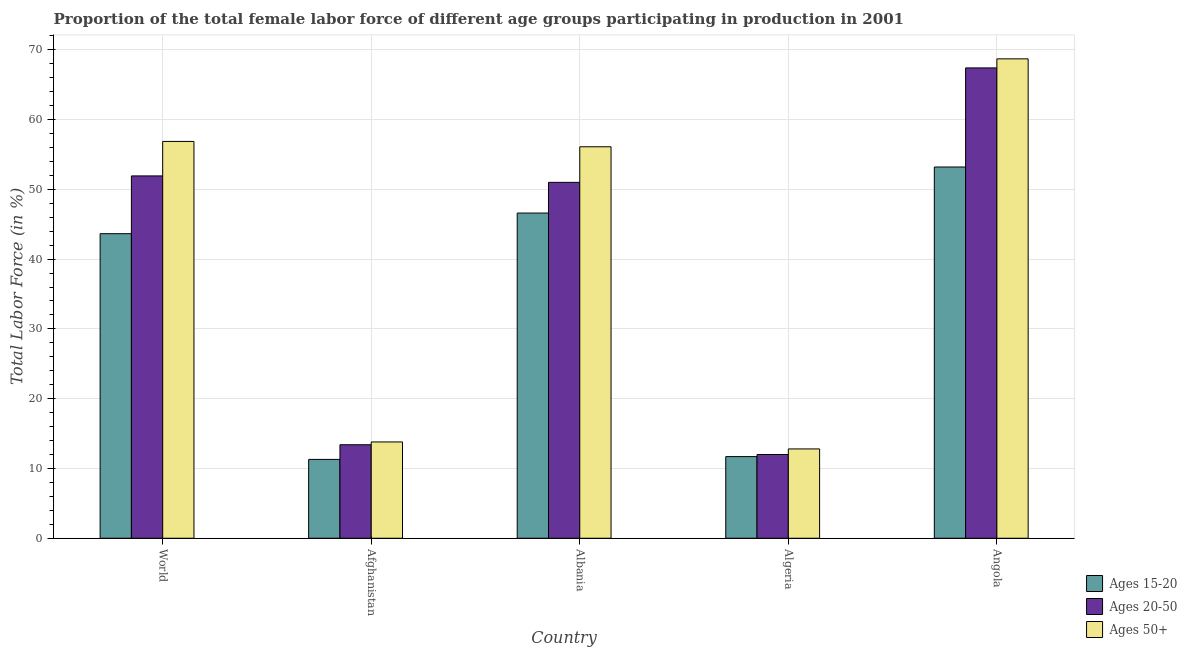How many different coloured bars are there?
Ensure brevity in your answer.  3. Are the number of bars per tick equal to the number of legend labels?
Your answer should be compact. Yes. What is the label of the 5th group of bars from the left?
Make the answer very short. Angola. What is the percentage of female labor force within the age group 15-20 in Algeria?
Your answer should be very brief. 11.7. Across all countries, what is the maximum percentage of female labor force within the age group 20-50?
Your response must be concise. 67.4. Across all countries, what is the minimum percentage of female labor force within the age group 20-50?
Offer a terse response. 12. In which country was the percentage of female labor force above age 50 maximum?
Provide a succinct answer. Angola. In which country was the percentage of female labor force above age 50 minimum?
Provide a succinct answer. Algeria. What is the total percentage of female labor force above age 50 in the graph?
Offer a very short reply. 208.27. What is the difference between the percentage of female labor force above age 50 in Afghanistan and that in Angola?
Make the answer very short. -54.9. What is the difference between the percentage of female labor force within the age group 15-20 in Angola and the percentage of female labor force within the age group 20-50 in Algeria?
Your answer should be very brief. 41.2. What is the average percentage of female labor force within the age group 20-50 per country?
Make the answer very short. 39.14. What is the difference between the percentage of female labor force within the age group 20-50 and percentage of female labor force above age 50 in World?
Keep it short and to the point. -4.94. What is the ratio of the percentage of female labor force within the age group 20-50 in Albania to that in Algeria?
Make the answer very short. 4.25. Is the percentage of female labor force within the age group 20-50 in Albania less than that in World?
Provide a succinct answer. Yes. What is the difference between the highest and the second highest percentage of female labor force within the age group 20-50?
Your answer should be very brief. 15.48. What is the difference between the highest and the lowest percentage of female labor force above age 50?
Offer a terse response. 55.9. In how many countries, is the percentage of female labor force above age 50 greater than the average percentage of female labor force above age 50 taken over all countries?
Make the answer very short. 3. Is the sum of the percentage of female labor force within the age group 20-50 in Albania and Angola greater than the maximum percentage of female labor force within the age group 15-20 across all countries?
Make the answer very short. Yes. What does the 1st bar from the left in Algeria represents?
Provide a succinct answer. Ages 15-20. What does the 3rd bar from the right in Angola represents?
Offer a terse response. Ages 15-20. Is it the case that in every country, the sum of the percentage of female labor force within the age group 15-20 and percentage of female labor force within the age group 20-50 is greater than the percentage of female labor force above age 50?
Your answer should be very brief. Yes. How many bars are there?
Keep it short and to the point. 15. Are all the bars in the graph horizontal?
Give a very brief answer. No. Where does the legend appear in the graph?
Offer a very short reply. Bottom right. What is the title of the graph?
Provide a succinct answer. Proportion of the total female labor force of different age groups participating in production in 2001. What is the label or title of the X-axis?
Keep it short and to the point. Country. What is the Total Labor Force (in %) of Ages 15-20 in World?
Make the answer very short. 43.64. What is the Total Labor Force (in %) of Ages 20-50 in World?
Make the answer very short. 51.92. What is the Total Labor Force (in %) of Ages 50+ in World?
Offer a terse response. 56.87. What is the Total Labor Force (in %) in Ages 15-20 in Afghanistan?
Your response must be concise. 11.3. What is the Total Labor Force (in %) in Ages 20-50 in Afghanistan?
Your response must be concise. 13.4. What is the Total Labor Force (in %) in Ages 50+ in Afghanistan?
Make the answer very short. 13.8. What is the Total Labor Force (in %) of Ages 15-20 in Albania?
Provide a short and direct response. 46.6. What is the Total Labor Force (in %) in Ages 50+ in Albania?
Keep it short and to the point. 56.1. What is the Total Labor Force (in %) in Ages 15-20 in Algeria?
Make the answer very short. 11.7. What is the Total Labor Force (in %) in Ages 20-50 in Algeria?
Offer a very short reply. 12. What is the Total Labor Force (in %) of Ages 50+ in Algeria?
Ensure brevity in your answer.  12.8. What is the Total Labor Force (in %) of Ages 15-20 in Angola?
Make the answer very short. 53.2. What is the Total Labor Force (in %) of Ages 20-50 in Angola?
Offer a very short reply. 67.4. What is the Total Labor Force (in %) of Ages 50+ in Angola?
Provide a short and direct response. 68.7. Across all countries, what is the maximum Total Labor Force (in %) in Ages 15-20?
Offer a terse response. 53.2. Across all countries, what is the maximum Total Labor Force (in %) in Ages 20-50?
Offer a terse response. 67.4. Across all countries, what is the maximum Total Labor Force (in %) of Ages 50+?
Your answer should be compact. 68.7. Across all countries, what is the minimum Total Labor Force (in %) of Ages 15-20?
Your answer should be very brief. 11.3. Across all countries, what is the minimum Total Labor Force (in %) of Ages 20-50?
Give a very brief answer. 12. Across all countries, what is the minimum Total Labor Force (in %) in Ages 50+?
Offer a terse response. 12.8. What is the total Total Labor Force (in %) in Ages 15-20 in the graph?
Provide a succinct answer. 166.44. What is the total Total Labor Force (in %) in Ages 20-50 in the graph?
Your answer should be very brief. 195.72. What is the total Total Labor Force (in %) in Ages 50+ in the graph?
Provide a short and direct response. 208.27. What is the difference between the Total Labor Force (in %) of Ages 15-20 in World and that in Afghanistan?
Offer a very short reply. 32.34. What is the difference between the Total Labor Force (in %) of Ages 20-50 in World and that in Afghanistan?
Your answer should be very brief. 38.52. What is the difference between the Total Labor Force (in %) in Ages 50+ in World and that in Afghanistan?
Your response must be concise. 43.07. What is the difference between the Total Labor Force (in %) of Ages 15-20 in World and that in Albania?
Your response must be concise. -2.96. What is the difference between the Total Labor Force (in %) of Ages 20-50 in World and that in Albania?
Your answer should be very brief. 0.92. What is the difference between the Total Labor Force (in %) of Ages 50+ in World and that in Albania?
Offer a very short reply. 0.77. What is the difference between the Total Labor Force (in %) of Ages 15-20 in World and that in Algeria?
Provide a short and direct response. 31.94. What is the difference between the Total Labor Force (in %) of Ages 20-50 in World and that in Algeria?
Your answer should be very brief. 39.92. What is the difference between the Total Labor Force (in %) in Ages 50+ in World and that in Algeria?
Give a very brief answer. 44.07. What is the difference between the Total Labor Force (in %) of Ages 15-20 in World and that in Angola?
Your answer should be compact. -9.56. What is the difference between the Total Labor Force (in %) in Ages 20-50 in World and that in Angola?
Provide a succinct answer. -15.48. What is the difference between the Total Labor Force (in %) of Ages 50+ in World and that in Angola?
Make the answer very short. -11.83. What is the difference between the Total Labor Force (in %) in Ages 15-20 in Afghanistan and that in Albania?
Your answer should be very brief. -35.3. What is the difference between the Total Labor Force (in %) in Ages 20-50 in Afghanistan and that in Albania?
Your answer should be compact. -37.6. What is the difference between the Total Labor Force (in %) in Ages 50+ in Afghanistan and that in Albania?
Provide a succinct answer. -42.3. What is the difference between the Total Labor Force (in %) in Ages 15-20 in Afghanistan and that in Algeria?
Offer a very short reply. -0.4. What is the difference between the Total Labor Force (in %) in Ages 20-50 in Afghanistan and that in Algeria?
Offer a terse response. 1.4. What is the difference between the Total Labor Force (in %) of Ages 15-20 in Afghanistan and that in Angola?
Your response must be concise. -41.9. What is the difference between the Total Labor Force (in %) of Ages 20-50 in Afghanistan and that in Angola?
Provide a succinct answer. -54. What is the difference between the Total Labor Force (in %) of Ages 50+ in Afghanistan and that in Angola?
Your answer should be compact. -54.9. What is the difference between the Total Labor Force (in %) of Ages 15-20 in Albania and that in Algeria?
Ensure brevity in your answer.  34.9. What is the difference between the Total Labor Force (in %) in Ages 50+ in Albania and that in Algeria?
Provide a short and direct response. 43.3. What is the difference between the Total Labor Force (in %) of Ages 20-50 in Albania and that in Angola?
Ensure brevity in your answer.  -16.4. What is the difference between the Total Labor Force (in %) of Ages 15-20 in Algeria and that in Angola?
Give a very brief answer. -41.5. What is the difference between the Total Labor Force (in %) of Ages 20-50 in Algeria and that in Angola?
Your answer should be compact. -55.4. What is the difference between the Total Labor Force (in %) of Ages 50+ in Algeria and that in Angola?
Your answer should be very brief. -55.9. What is the difference between the Total Labor Force (in %) in Ages 15-20 in World and the Total Labor Force (in %) in Ages 20-50 in Afghanistan?
Your answer should be compact. 30.24. What is the difference between the Total Labor Force (in %) of Ages 15-20 in World and the Total Labor Force (in %) of Ages 50+ in Afghanistan?
Ensure brevity in your answer.  29.84. What is the difference between the Total Labor Force (in %) in Ages 20-50 in World and the Total Labor Force (in %) in Ages 50+ in Afghanistan?
Your answer should be very brief. 38.12. What is the difference between the Total Labor Force (in %) of Ages 15-20 in World and the Total Labor Force (in %) of Ages 20-50 in Albania?
Make the answer very short. -7.36. What is the difference between the Total Labor Force (in %) of Ages 15-20 in World and the Total Labor Force (in %) of Ages 50+ in Albania?
Provide a short and direct response. -12.46. What is the difference between the Total Labor Force (in %) of Ages 20-50 in World and the Total Labor Force (in %) of Ages 50+ in Albania?
Offer a terse response. -4.18. What is the difference between the Total Labor Force (in %) of Ages 15-20 in World and the Total Labor Force (in %) of Ages 20-50 in Algeria?
Give a very brief answer. 31.64. What is the difference between the Total Labor Force (in %) in Ages 15-20 in World and the Total Labor Force (in %) in Ages 50+ in Algeria?
Your answer should be very brief. 30.84. What is the difference between the Total Labor Force (in %) in Ages 20-50 in World and the Total Labor Force (in %) in Ages 50+ in Algeria?
Offer a very short reply. 39.12. What is the difference between the Total Labor Force (in %) of Ages 15-20 in World and the Total Labor Force (in %) of Ages 20-50 in Angola?
Offer a very short reply. -23.76. What is the difference between the Total Labor Force (in %) in Ages 15-20 in World and the Total Labor Force (in %) in Ages 50+ in Angola?
Your response must be concise. -25.06. What is the difference between the Total Labor Force (in %) in Ages 20-50 in World and the Total Labor Force (in %) in Ages 50+ in Angola?
Provide a short and direct response. -16.78. What is the difference between the Total Labor Force (in %) of Ages 15-20 in Afghanistan and the Total Labor Force (in %) of Ages 20-50 in Albania?
Offer a terse response. -39.7. What is the difference between the Total Labor Force (in %) in Ages 15-20 in Afghanistan and the Total Labor Force (in %) in Ages 50+ in Albania?
Give a very brief answer. -44.8. What is the difference between the Total Labor Force (in %) in Ages 20-50 in Afghanistan and the Total Labor Force (in %) in Ages 50+ in Albania?
Your response must be concise. -42.7. What is the difference between the Total Labor Force (in %) in Ages 15-20 in Afghanistan and the Total Labor Force (in %) in Ages 20-50 in Algeria?
Make the answer very short. -0.7. What is the difference between the Total Labor Force (in %) of Ages 15-20 in Afghanistan and the Total Labor Force (in %) of Ages 20-50 in Angola?
Make the answer very short. -56.1. What is the difference between the Total Labor Force (in %) in Ages 15-20 in Afghanistan and the Total Labor Force (in %) in Ages 50+ in Angola?
Keep it short and to the point. -57.4. What is the difference between the Total Labor Force (in %) of Ages 20-50 in Afghanistan and the Total Labor Force (in %) of Ages 50+ in Angola?
Your response must be concise. -55.3. What is the difference between the Total Labor Force (in %) in Ages 15-20 in Albania and the Total Labor Force (in %) in Ages 20-50 in Algeria?
Offer a very short reply. 34.6. What is the difference between the Total Labor Force (in %) of Ages 15-20 in Albania and the Total Labor Force (in %) of Ages 50+ in Algeria?
Make the answer very short. 33.8. What is the difference between the Total Labor Force (in %) in Ages 20-50 in Albania and the Total Labor Force (in %) in Ages 50+ in Algeria?
Give a very brief answer. 38.2. What is the difference between the Total Labor Force (in %) of Ages 15-20 in Albania and the Total Labor Force (in %) of Ages 20-50 in Angola?
Your response must be concise. -20.8. What is the difference between the Total Labor Force (in %) of Ages 15-20 in Albania and the Total Labor Force (in %) of Ages 50+ in Angola?
Your answer should be compact. -22.1. What is the difference between the Total Labor Force (in %) of Ages 20-50 in Albania and the Total Labor Force (in %) of Ages 50+ in Angola?
Your answer should be compact. -17.7. What is the difference between the Total Labor Force (in %) in Ages 15-20 in Algeria and the Total Labor Force (in %) in Ages 20-50 in Angola?
Your response must be concise. -55.7. What is the difference between the Total Labor Force (in %) in Ages 15-20 in Algeria and the Total Labor Force (in %) in Ages 50+ in Angola?
Ensure brevity in your answer.  -57. What is the difference between the Total Labor Force (in %) in Ages 20-50 in Algeria and the Total Labor Force (in %) in Ages 50+ in Angola?
Ensure brevity in your answer.  -56.7. What is the average Total Labor Force (in %) of Ages 15-20 per country?
Ensure brevity in your answer.  33.29. What is the average Total Labor Force (in %) in Ages 20-50 per country?
Ensure brevity in your answer.  39.14. What is the average Total Labor Force (in %) in Ages 50+ per country?
Provide a short and direct response. 41.65. What is the difference between the Total Labor Force (in %) of Ages 15-20 and Total Labor Force (in %) of Ages 20-50 in World?
Keep it short and to the point. -8.28. What is the difference between the Total Labor Force (in %) of Ages 15-20 and Total Labor Force (in %) of Ages 50+ in World?
Your answer should be compact. -13.22. What is the difference between the Total Labor Force (in %) in Ages 20-50 and Total Labor Force (in %) in Ages 50+ in World?
Your answer should be very brief. -4.94. What is the difference between the Total Labor Force (in %) of Ages 15-20 and Total Labor Force (in %) of Ages 20-50 in Afghanistan?
Your answer should be compact. -2.1. What is the difference between the Total Labor Force (in %) in Ages 15-20 and Total Labor Force (in %) in Ages 50+ in Afghanistan?
Your response must be concise. -2.5. What is the difference between the Total Labor Force (in %) of Ages 20-50 and Total Labor Force (in %) of Ages 50+ in Afghanistan?
Give a very brief answer. -0.4. What is the difference between the Total Labor Force (in %) in Ages 15-20 and Total Labor Force (in %) in Ages 20-50 in Albania?
Your answer should be compact. -4.4. What is the difference between the Total Labor Force (in %) in Ages 15-20 and Total Labor Force (in %) in Ages 20-50 in Algeria?
Give a very brief answer. -0.3. What is the difference between the Total Labor Force (in %) of Ages 15-20 and Total Labor Force (in %) of Ages 50+ in Angola?
Your answer should be compact. -15.5. What is the difference between the Total Labor Force (in %) of Ages 20-50 and Total Labor Force (in %) of Ages 50+ in Angola?
Provide a short and direct response. -1.3. What is the ratio of the Total Labor Force (in %) in Ages 15-20 in World to that in Afghanistan?
Make the answer very short. 3.86. What is the ratio of the Total Labor Force (in %) in Ages 20-50 in World to that in Afghanistan?
Make the answer very short. 3.87. What is the ratio of the Total Labor Force (in %) of Ages 50+ in World to that in Afghanistan?
Ensure brevity in your answer.  4.12. What is the ratio of the Total Labor Force (in %) in Ages 15-20 in World to that in Albania?
Give a very brief answer. 0.94. What is the ratio of the Total Labor Force (in %) in Ages 20-50 in World to that in Albania?
Your answer should be very brief. 1.02. What is the ratio of the Total Labor Force (in %) in Ages 50+ in World to that in Albania?
Make the answer very short. 1.01. What is the ratio of the Total Labor Force (in %) in Ages 15-20 in World to that in Algeria?
Provide a short and direct response. 3.73. What is the ratio of the Total Labor Force (in %) of Ages 20-50 in World to that in Algeria?
Your answer should be compact. 4.33. What is the ratio of the Total Labor Force (in %) of Ages 50+ in World to that in Algeria?
Ensure brevity in your answer.  4.44. What is the ratio of the Total Labor Force (in %) in Ages 15-20 in World to that in Angola?
Your answer should be very brief. 0.82. What is the ratio of the Total Labor Force (in %) of Ages 20-50 in World to that in Angola?
Your answer should be compact. 0.77. What is the ratio of the Total Labor Force (in %) of Ages 50+ in World to that in Angola?
Offer a terse response. 0.83. What is the ratio of the Total Labor Force (in %) in Ages 15-20 in Afghanistan to that in Albania?
Your answer should be very brief. 0.24. What is the ratio of the Total Labor Force (in %) in Ages 20-50 in Afghanistan to that in Albania?
Ensure brevity in your answer.  0.26. What is the ratio of the Total Labor Force (in %) in Ages 50+ in Afghanistan to that in Albania?
Provide a succinct answer. 0.25. What is the ratio of the Total Labor Force (in %) in Ages 15-20 in Afghanistan to that in Algeria?
Keep it short and to the point. 0.97. What is the ratio of the Total Labor Force (in %) in Ages 20-50 in Afghanistan to that in Algeria?
Keep it short and to the point. 1.12. What is the ratio of the Total Labor Force (in %) in Ages 50+ in Afghanistan to that in Algeria?
Your response must be concise. 1.08. What is the ratio of the Total Labor Force (in %) of Ages 15-20 in Afghanistan to that in Angola?
Make the answer very short. 0.21. What is the ratio of the Total Labor Force (in %) in Ages 20-50 in Afghanistan to that in Angola?
Offer a very short reply. 0.2. What is the ratio of the Total Labor Force (in %) of Ages 50+ in Afghanistan to that in Angola?
Offer a terse response. 0.2. What is the ratio of the Total Labor Force (in %) of Ages 15-20 in Albania to that in Algeria?
Provide a short and direct response. 3.98. What is the ratio of the Total Labor Force (in %) in Ages 20-50 in Albania to that in Algeria?
Make the answer very short. 4.25. What is the ratio of the Total Labor Force (in %) in Ages 50+ in Albania to that in Algeria?
Provide a short and direct response. 4.38. What is the ratio of the Total Labor Force (in %) in Ages 15-20 in Albania to that in Angola?
Make the answer very short. 0.88. What is the ratio of the Total Labor Force (in %) in Ages 20-50 in Albania to that in Angola?
Provide a succinct answer. 0.76. What is the ratio of the Total Labor Force (in %) of Ages 50+ in Albania to that in Angola?
Make the answer very short. 0.82. What is the ratio of the Total Labor Force (in %) of Ages 15-20 in Algeria to that in Angola?
Your answer should be compact. 0.22. What is the ratio of the Total Labor Force (in %) in Ages 20-50 in Algeria to that in Angola?
Your answer should be compact. 0.18. What is the ratio of the Total Labor Force (in %) in Ages 50+ in Algeria to that in Angola?
Give a very brief answer. 0.19. What is the difference between the highest and the second highest Total Labor Force (in %) in Ages 15-20?
Your answer should be compact. 6.6. What is the difference between the highest and the second highest Total Labor Force (in %) of Ages 20-50?
Provide a short and direct response. 15.48. What is the difference between the highest and the second highest Total Labor Force (in %) of Ages 50+?
Give a very brief answer. 11.83. What is the difference between the highest and the lowest Total Labor Force (in %) of Ages 15-20?
Ensure brevity in your answer.  41.9. What is the difference between the highest and the lowest Total Labor Force (in %) of Ages 20-50?
Provide a short and direct response. 55.4. What is the difference between the highest and the lowest Total Labor Force (in %) in Ages 50+?
Ensure brevity in your answer.  55.9. 